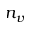Convert formula to latex. <formula><loc_0><loc_0><loc_500><loc_500>n _ { v }</formula> 